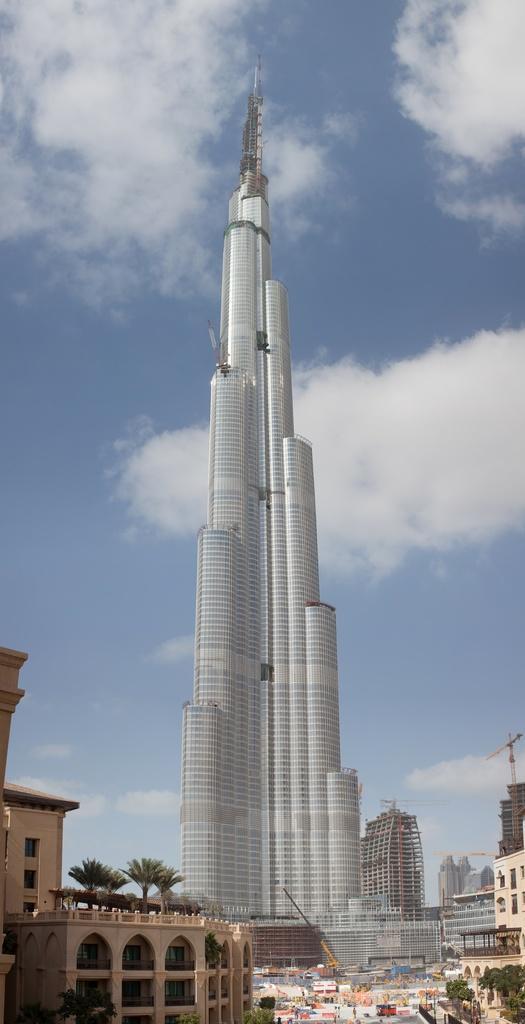How would you summarize this image in a sentence or two? In this image I can see number of buildings, the Burj Khalifa and on the both sides of the image I can see number of trees. In the background I can see clouds and the sky. 